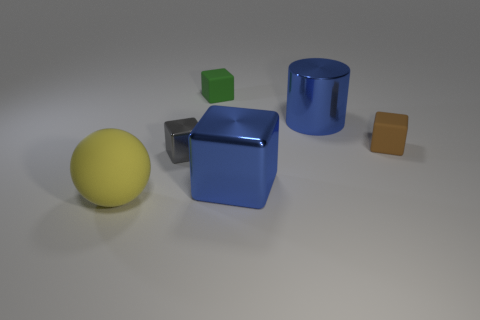Subtract all large blue blocks. How many blocks are left? 3 Add 4 big gray rubber spheres. How many objects exist? 10 Subtract all brown blocks. How many blocks are left? 3 Subtract 2 blocks. How many blocks are left? 2 Subtract all spheres. How many objects are left? 5 Subtract all purple blocks. Subtract all green cylinders. How many blocks are left? 4 Subtract 0 gray balls. How many objects are left? 6 Subtract all big purple metallic cylinders. Subtract all blue metallic things. How many objects are left? 4 Add 2 big blue shiny cubes. How many big blue shiny cubes are left? 3 Add 6 gray shiny objects. How many gray shiny objects exist? 7 